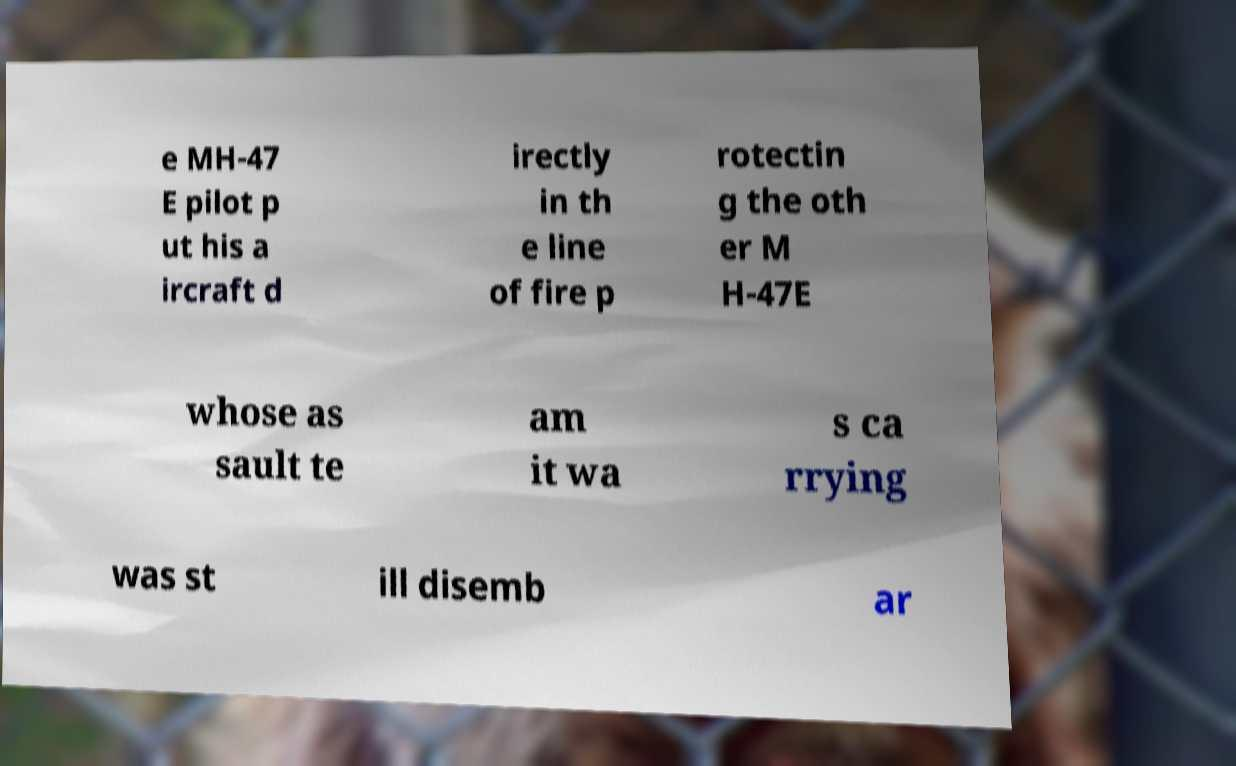Could you extract and type out the text from this image? e MH-47 E pilot p ut his a ircraft d irectly in th e line of fire p rotectin g the oth er M H-47E whose as sault te am it wa s ca rrying was st ill disemb ar 